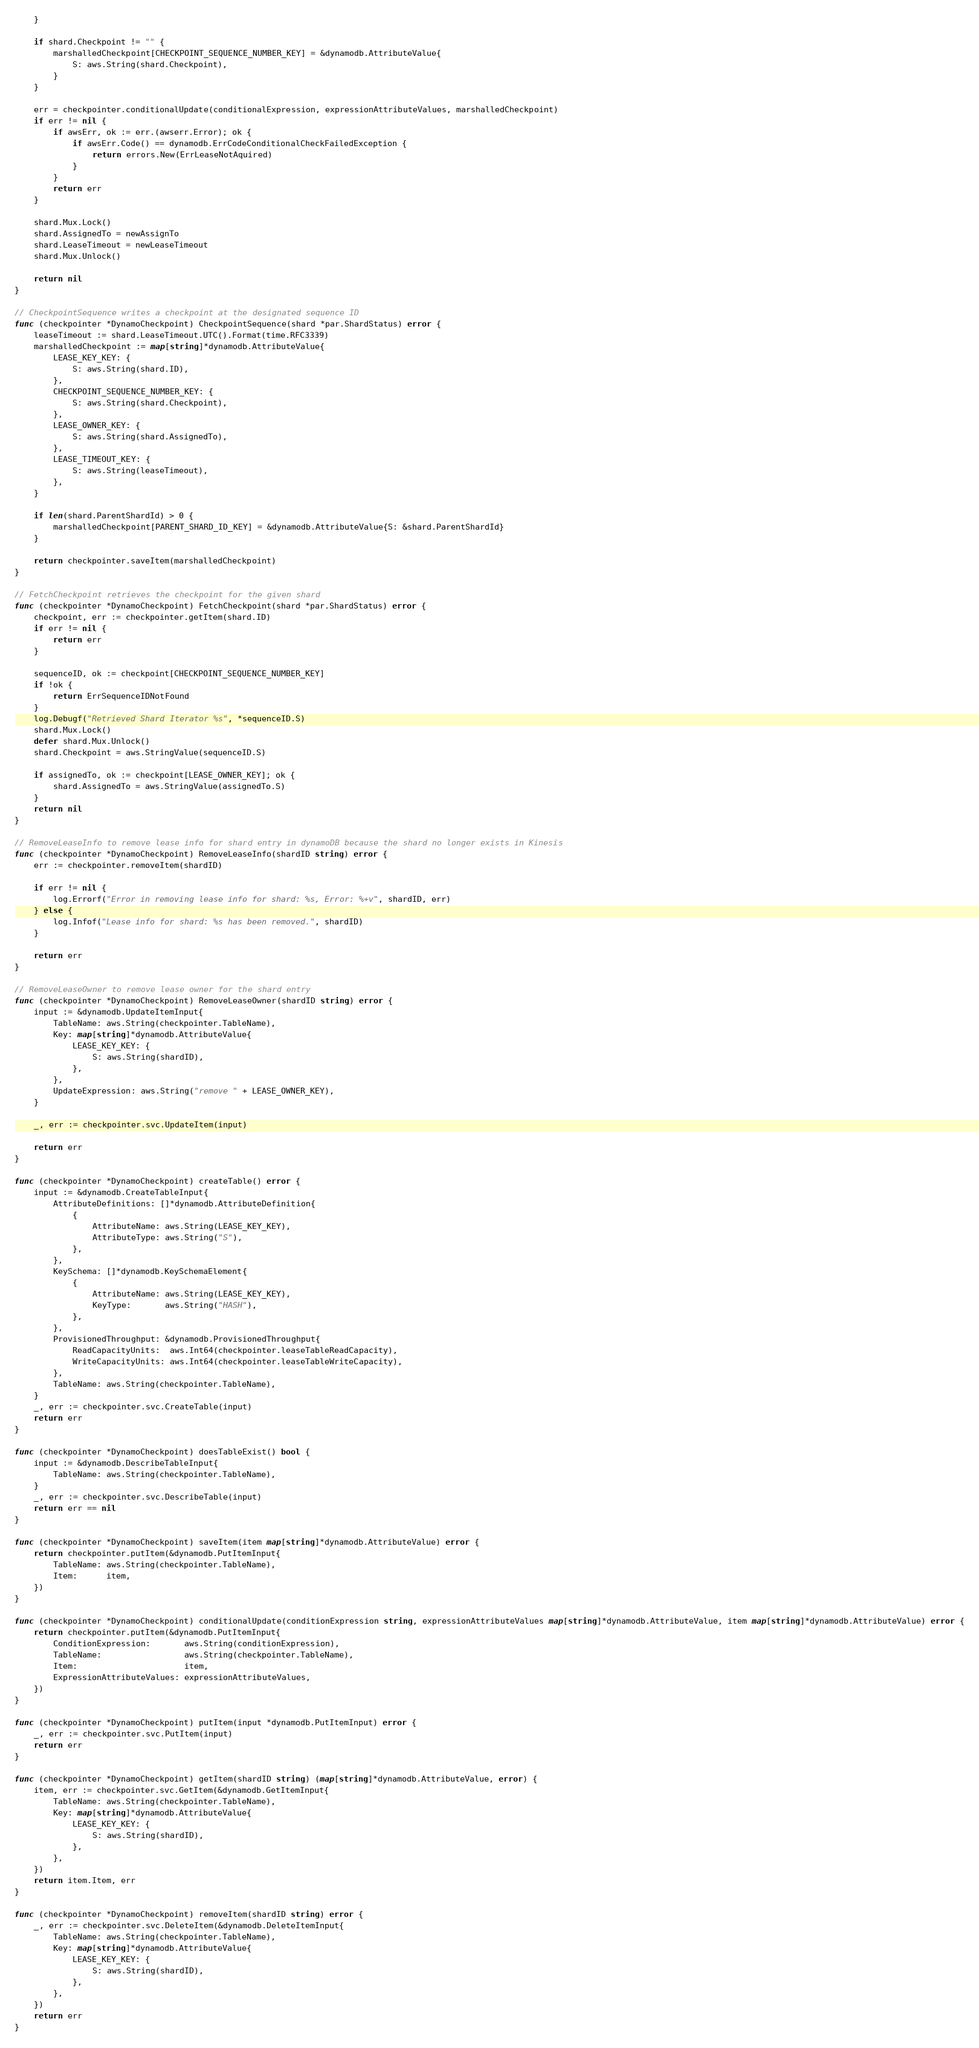<code> <loc_0><loc_0><loc_500><loc_500><_Go_>	}

	if shard.Checkpoint != "" {
		marshalledCheckpoint[CHECKPOINT_SEQUENCE_NUMBER_KEY] = &dynamodb.AttributeValue{
			S: aws.String(shard.Checkpoint),
		}
	}

	err = checkpointer.conditionalUpdate(conditionalExpression, expressionAttributeValues, marshalledCheckpoint)
	if err != nil {
		if awsErr, ok := err.(awserr.Error); ok {
			if awsErr.Code() == dynamodb.ErrCodeConditionalCheckFailedException {
				return errors.New(ErrLeaseNotAquired)
			}
		}
		return err
	}

	shard.Mux.Lock()
	shard.AssignedTo = newAssignTo
	shard.LeaseTimeout = newLeaseTimeout
	shard.Mux.Unlock()

	return nil
}

// CheckpointSequence writes a checkpoint at the designated sequence ID
func (checkpointer *DynamoCheckpoint) CheckpointSequence(shard *par.ShardStatus) error {
	leaseTimeout := shard.LeaseTimeout.UTC().Format(time.RFC3339)
	marshalledCheckpoint := map[string]*dynamodb.AttributeValue{
		LEASE_KEY_KEY: {
			S: aws.String(shard.ID),
		},
		CHECKPOINT_SEQUENCE_NUMBER_KEY: {
			S: aws.String(shard.Checkpoint),
		},
		LEASE_OWNER_KEY: {
			S: aws.String(shard.AssignedTo),
		},
		LEASE_TIMEOUT_KEY: {
			S: aws.String(leaseTimeout),
		},
	}

	if len(shard.ParentShardId) > 0 {
		marshalledCheckpoint[PARENT_SHARD_ID_KEY] = &dynamodb.AttributeValue{S: &shard.ParentShardId}
	}

	return checkpointer.saveItem(marshalledCheckpoint)
}

// FetchCheckpoint retrieves the checkpoint for the given shard
func (checkpointer *DynamoCheckpoint) FetchCheckpoint(shard *par.ShardStatus) error {
	checkpoint, err := checkpointer.getItem(shard.ID)
	if err != nil {
		return err
	}

	sequenceID, ok := checkpoint[CHECKPOINT_SEQUENCE_NUMBER_KEY]
	if !ok {
		return ErrSequenceIDNotFound
	}
	log.Debugf("Retrieved Shard Iterator %s", *sequenceID.S)
	shard.Mux.Lock()
	defer shard.Mux.Unlock()
	shard.Checkpoint = aws.StringValue(sequenceID.S)

	if assignedTo, ok := checkpoint[LEASE_OWNER_KEY]; ok {
		shard.AssignedTo = aws.StringValue(assignedTo.S)
	}
	return nil
}

// RemoveLeaseInfo to remove lease info for shard entry in dynamoDB because the shard no longer exists in Kinesis
func (checkpointer *DynamoCheckpoint) RemoveLeaseInfo(shardID string) error {
	err := checkpointer.removeItem(shardID)

	if err != nil {
		log.Errorf("Error in removing lease info for shard: %s, Error: %+v", shardID, err)
	} else {
		log.Infof("Lease info for shard: %s has been removed.", shardID)
	}

	return err
}

// RemoveLeaseOwner to remove lease owner for the shard entry
func (checkpointer *DynamoCheckpoint) RemoveLeaseOwner(shardID string) error {
	input := &dynamodb.UpdateItemInput{
		TableName: aws.String(checkpointer.TableName),
		Key: map[string]*dynamodb.AttributeValue{
			LEASE_KEY_KEY: {
				S: aws.String(shardID),
			},
		},
		UpdateExpression: aws.String("remove " + LEASE_OWNER_KEY),
	}

	_, err := checkpointer.svc.UpdateItem(input)

	return err
}

func (checkpointer *DynamoCheckpoint) createTable() error {
	input := &dynamodb.CreateTableInput{
		AttributeDefinitions: []*dynamodb.AttributeDefinition{
			{
				AttributeName: aws.String(LEASE_KEY_KEY),
				AttributeType: aws.String("S"),
			},
		},
		KeySchema: []*dynamodb.KeySchemaElement{
			{
				AttributeName: aws.String(LEASE_KEY_KEY),
				KeyType:       aws.String("HASH"),
			},
		},
		ProvisionedThroughput: &dynamodb.ProvisionedThroughput{
			ReadCapacityUnits:  aws.Int64(checkpointer.leaseTableReadCapacity),
			WriteCapacityUnits: aws.Int64(checkpointer.leaseTableWriteCapacity),
		},
		TableName: aws.String(checkpointer.TableName),
	}
	_, err := checkpointer.svc.CreateTable(input)
	return err
}

func (checkpointer *DynamoCheckpoint) doesTableExist() bool {
	input := &dynamodb.DescribeTableInput{
		TableName: aws.String(checkpointer.TableName),
	}
	_, err := checkpointer.svc.DescribeTable(input)
	return err == nil
}

func (checkpointer *DynamoCheckpoint) saveItem(item map[string]*dynamodb.AttributeValue) error {
	return checkpointer.putItem(&dynamodb.PutItemInput{
		TableName: aws.String(checkpointer.TableName),
		Item:      item,
	})
}

func (checkpointer *DynamoCheckpoint) conditionalUpdate(conditionExpression string, expressionAttributeValues map[string]*dynamodb.AttributeValue, item map[string]*dynamodb.AttributeValue) error {
	return checkpointer.putItem(&dynamodb.PutItemInput{
		ConditionExpression:       aws.String(conditionExpression),
		TableName:                 aws.String(checkpointer.TableName),
		Item:                      item,
		ExpressionAttributeValues: expressionAttributeValues,
	})
}

func (checkpointer *DynamoCheckpoint) putItem(input *dynamodb.PutItemInput) error {
	_, err := checkpointer.svc.PutItem(input)
	return err
}

func (checkpointer *DynamoCheckpoint) getItem(shardID string) (map[string]*dynamodb.AttributeValue, error) {
	item, err := checkpointer.svc.GetItem(&dynamodb.GetItemInput{
		TableName: aws.String(checkpointer.TableName),
		Key: map[string]*dynamodb.AttributeValue{
			LEASE_KEY_KEY: {
				S: aws.String(shardID),
			},
		},
	})
	return item.Item, err
}

func (checkpointer *DynamoCheckpoint) removeItem(shardID string) error {
	_, err := checkpointer.svc.DeleteItem(&dynamodb.DeleteItemInput{
		TableName: aws.String(checkpointer.TableName),
		Key: map[string]*dynamodb.AttributeValue{
			LEASE_KEY_KEY: {
				S: aws.String(shardID),
			},
		},
	})
	return err
}
</code> 